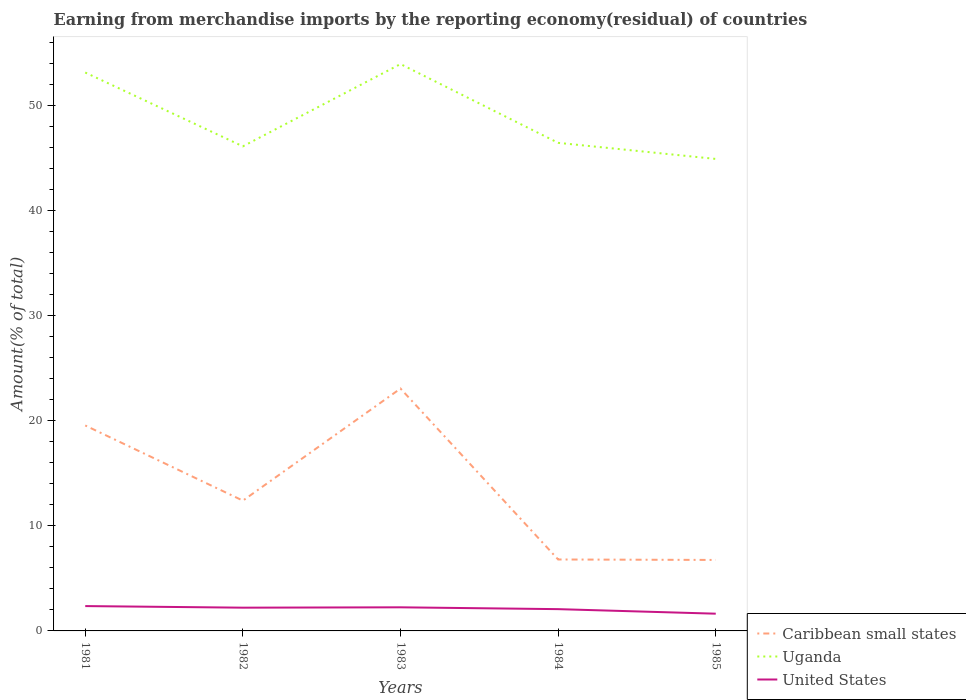Across all years, what is the maximum percentage of amount earned from merchandise imports in Uganda?
Give a very brief answer. 44.92. In which year was the percentage of amount earned from merchandise imports in Caribbean small states maximum?
Provide a succinct answer. 1985. What is the total percentage of amount earned from merchandise imports in United States in the graph?
Offer a very short reply. 0.12. What is the difference between the highest and the second highest percentage of amount earned from merchandise imports in United States?
Offer a very short reply. 0.73. What is the difference between the highest and the lowest percentage of amount earned from merchandise imports in Uganda?
Your answer should be compact. 2. Is the percentage of amount earned from merchandise imports in Caribbean small states strictly greater than the percentage of amount earned from merchandise imports in United States over the years?
Your answer should be very brief. No. How many lines are there?
Your answer should be compact. 3. What is the difference between two consecutive major ticks on the Y-axis?
Provide a short and direct response. 10. Does the graph contain grids?
Offer a terse response. No. Where does the legend appear in the graph?
Keep it short and to the point. Bottom right. How many legend labels are there?
Your answer should be very brief. 3. How are the legend labels stacked?
Your response must be concise. Vertical. What is the title of the graph?
Provide a succinct answer. Earning from merchandise imports by the reporting economy(residual) of countries. What is the label or title of the X-axis?
Give a very brief answer. Years. What is the label or title of the Y-axis?
Provide a short and direct response. Amount(% of total). What is the Amount(% of total) in Caribbean small states in 1981?
Keep it short and to the point. 19.55. What is the Amount(% of total) in Uganda in 1981?
Offer a terse response. 53.14. What is the Amount(% of total) in United States in 1981?
Ensure brevity in your answer.  2.36. What is the Amount(% of total) in Caribbean small states in 1982?
Provide a short and direct response. 12.4. What is the Amount(% of total) of Uganda in 1982?
Keep it short and to the point. 46.12. What is the Amount(% of total) in United States in 1982?
Your response must be concise. 2.21. What is the Amount(% of total) of Caribbean small states in 1983?
Make the answer very short. 23.07. What is the Amount(% of total) in Uganda in 1983?
Ensure brevity in your answer.  53.95. What is the Amount(% of total) of United States in 1983?
Offer a terse response. 2.25. What is the Amount(% of total) of Caribbean small states in 1984?
Keep it short and to the point. 6.8. What is the Amount(% of total) of Uganda in 1984?
Provide a short and direct response. 46.45. What is the Amount(% of total) of United States in 1984?
Make the answer very short. 2.07. What is the Amount(% of total) in Caribbean small states in 1985?
Make the answer very short. 6.75. What is the Amount(% of total) of Uganda in 1985?
Your answer should be compact. 44.92. What is the Amount(% of total) in United States in 1985?
Offer a very short reply. 1.64. Across all years, what is the maximum Amount(% of total) in Caribbean small states?
Your answer should be very brief. 23.07. Across all years, what is the maximum Amount(% of total) in Uganda?
Give a very brief answer. 53.95. Across all years, what is the maximum Amount(% of total) of United States?
Offer a very short reply. 2.36. Across all years, what is the minimum Amount(% of total) in Caribbean small states?
Ensure brevity in your answer.  6.75. Across all years, what is the minimum Amount(% of total) in Uganda?
Keep it short and to the point. 44.92. Across all years, what is the minimum Amount(% of total) of United States?
Give a very brief answer. 1.64. What is the total Amount(% of total) of Caribbean small states in the graph?
Offer a terse response. 68.57. What is the total Amount(% of total) in Uganda in the graph?
Give a very brief answer. 244.57. What is the total Amount(% of total) in United States in the graph?
Keep it short and to the point. 10.54. What is the difference between the Amount(% of total) in Caribbean small states in 1981 and that in 1982?
Make the answer very short. 7.15. What is the difference between the Amount(% of total) in Uganda in 1981 and that in 1982?
Your response must be concise. 7.03. What is the difference between the Amount(% of total) of United States in 1981 and that in 1982?
Ensure brevity in your answer.  0.15. What is the difference between the Amount(% of total) in Caribbean small states in 1981 and that in 1983?
Make the answer very short. -3.51. What is the difference between the Amount(% of total) in Uganda in 1981 and that in 1983?
Your response must be concise. -0.81. What is the difference between the Amount(% of total) in United States in 1981 and that in 1983?
Make the answer very short. 0.12. What is the difference between the Amount(% of total) in Caribbean small states in 1981 and that in 1984?
Provide a short and direct response. 12.75. What is the difference between the Amount(% of total) in Uganda in 1981 and that in 1984?
Ensure brevity in your answer.  6.69. What is the difference between the Amount(% of total) of United States in 1981 and that in 1984?
Make the answer very short. 0.29. What is the difference between the Amount(% of total) in Caribbean small states in 1981 and that in 1985?
Give a very brief answer. 12.8. What is the difference between the Amount(% of total) of Uganda in 1981 and that in 1985?
Make the answer very short. 8.22. What is the difference between the Amount(% of total) in United States in 1981 and that in 1985?
Keep it short and to the point. 0.73. What is the difference between the Amount(% of total) of Caribbean small states in 1982 and that in 1983?
Keep it short and to the point. -10.67. What is the difference between the Amount(% of total) in Uganda in 1982 and that in 1983?
Make the answer very short. -7.83. What is the difference between the Amount(% of total) of United States in 1982 and that in 1983?
Ensure brevity in your answer.  -0.03. What is the difference between the Amount(% of total) in Caribbean small states in 1982 and that in 1984?
Your response must be concise. 5.6. What is the difference between the Amount(% of total) of Uganda in 1982 and that in 1984?
Ensure brevity in your answer.  -0.33. What is the difference between the Amount(% of total) in United States in 1982 and that in 1984?
Give a very brief answer. 0.14. What is the difference between the Amount(% of total) of Caribbean small states in 1982 and that in 1985?
Make the answer very short. 5.65. What is the difference between the Amount(% of total) of Uganda in 1982 and that in 1985?
Provide a succinct answer. 1.2. What is the difference between the Amount(% of total) of United States in 1982 and that in 1985?
Give a very brief answer. 0.57. What is the difference between the Amount(% of total) of Caribbean small states in 1983 and that in 1984?
Ensure brevity in your answer.  16.27. What is the difference between the Amount(% of total) of Uganda in 1983 and that in 1984?
Keep it short and to the point. 7.5. What is the difference between the Amount(% of total) of United States in 1983 and that in 1984?
Your response must be concise. 0.17. What is the difference between the Amount(% of total) in Caribbean small states in 1983 and that in 1985?
Offer a terse response. 16.31. What is the difference between the Amount(% of total) of Uganda in 1983 and that in 1985?
Offer a terse response. 9.03. What is the difference between the Amount(% of total) in United States in 1983 and that in 1985?
Offer a very short reply. 0.61. What is the difference between the Amount(% of total) of Caribbean small states in 1984 and that in 1985?
Your answer should be very brief. 0.04. What is the difference between the Amount(% of total) in Uganda in 1984 and that in 1985?
Provide a succinct answer. 1.53. What is the difference between the Amount(% of total) of United States in 1984 and that in 1985?
Offer a terse response. 0.43. What is the difference between the Amount(% of total) in Caribbean small states in 1981 and the Amount(% of total) in Uganda in 1982?
Your response must be concise. -26.56. What is the difference between the Amount(% of total) of Caribbean small states in 1981 and the Amount(% of total) of United States in 1982?
Provide a short and direct response. 17.34. What is the difference between the Amount(% of total) in Uganda in 1981 and the Amount(% of total) in United States in 1982?
Your response must be concise. 50.93. What is the difference between the Amount(% of total) of Caribbean small states in 1981 and the Amount(% of total) of Uganda in 1983?
Make the answer very short. -34.39. What is the difference between the Amount(% of total) of Caribbean small states in 1981 and the Amount(% of total) of United States in 1983?
Give a very brief answer. 17.31. What is the difference between the Amount(% of total) in Uganda in 1981 and the Amount(% of total) in United States in 1983?
Make the answer very short. 50.9. What is the difference between the Amount(% of total) in Caribbean small states in 1981 and the Amount(% of total) in Uganda in 1984?
Offer a terse response. -26.9. What is the difference between the Amount(% of total) of Caribbean small states in 1981 and the Amount(% of total) of United States in 1984?
Make the answer very short. 17.48. What is the difference between the Amount(% of total) in Uganda in 1981 and the Amount(% of total) in United States in 1984?
Ensure brevity in your answer.  51.07. What is the difference between the Amount(% of total) of Caribbean small states in 1981 and the Amount(% of total) of Uganda in 1985?
Your answer should be very brief. -25.37. What is the difference between the Amount(% of total) in Caribbean small states in 1981 and the Amount(% of total) in United States in 1985?
Make the answer very short. 17.91. What is the difference between the Amount(% of total) of Uganda in 1981 and the Amount(% of total) of United States in 1985?
Offer a very short reply. 51.5. What is the difference between the Amount(% of total) of Caribbean small states in 1982 and the Amount(% of total) of Uganda in 1983?
Your answer should be compact. -41.55. What is the difference between the Amount(% of total) of Caribbean small states in 1982 and the Amount(% of total) of United States in 1983?
Offer a very short reply. 10.15. What is the difference between the Amount(% of total) in Uganda in 1982 and the Amount(% of total) in United States in 1983?
Provide a succinct answer. 43.87. What is the difference between the Amount(% of total) of Caribbean small states in 1982 and the Amount(% of total) of Uganda in 1984?
Keep it short and to the point. -34.05. What is the difference between the Amount(% of total) in Caribbean small states in 1982 and the Amount(% of total) in United States in 1984?
Your answer should be very brief. 10.33. What is the difference between the Amount(% of total) in Uganda in 1982 and the Amount(% of total) in United States in 1984?
Make the answer very short. 44.04. What is the difference between the Amount(% of total) of Caribbean small states in 1982 and the Amount(% of total) of Uganda in 1985?
Provide a succinct answer. -32.52. What is the difference between the Amount(% of total) in Caribbean small states in 1982 and the Amount(% of total) in United States in 1985?
Give a very brief answer. 10.76. What is the difference between the Amount(% of total) in Uganda in 1982 and the Amount(% of total) in United States in 1985?
Give a very brief answer. 44.48. What is the difference between the Amount(% of total) of Caribbean small states in 1983 and the Amount(% of total) of Uganda in 1984?
Make the answer very short. -23.38. What is the difference between the Amount(% of total) in Caribbean small states in 1983 and the Amount(% of total) in United States in 1984?
Provide a short and direct response. 20.99. What is the difference between the Amount(% of total) of Uganda in 1983 and the Amount(% of total) of United States in 1984?
Keep it short and to the point. 51.88. What is the difference between the Amount(% of total) of Caribbean small states in 1983 and the Amount(% of total) of Uganda in 1985?
Ensure brevity in your answer.  -21.85. What is the difference between the Amount(% of total) of Caribbean small states in 1983 and the Amount(% of total) of United States in 1985?
Provide a succinct answer. 21.43. What is the difference between the Amount(% of total) of Uganda in 1983 and the Amount(% of total) of United States in 1985?
Ensure brevity in your answer.  52.31. What is the difference between the Amount(% of total) in Caribbean small states in 1984 and the Amount(% of total) in Uganda in 1985?
Ensure brevity in your answer.  -38.12. What is the difference between the Amount(% of total) of Caribbean small states in 1984 and the Amount(% of total) of United States in 1985?
Your response must be concise. 5.16. What is the difference between the Amount(% of total) of Uganda in 1984 and the Amount(% of total) of United States in 1985?
Give a very brief answer. 44.81. What is the average Amount(% of total) of Caribbean small states per year?
Offer a very short reply. 13.71. What is the average Amount(% of total) of Uganda per year?
Provide a succinct answer. 48.91. What is the average Amount(% of total) in United States per year?
Your answer should be very brief. 2.11. In the year 1981, what is the difference between the Amount(% of total) of Caribbean small states and Amount(% of total) of Uganda?
Provide a succinct answer. -33.59. In the year 1981, what is the difference between the Amount(% of total) in Caribbean small states and Amount(% of total) in United States?
Your response must be concise. 17.19. In the year 1981, what is the difference between the Amount(% of total) in Uganda and Amount(% of total) in United States?
Offer a terse response. 50.78. In the year 1982, what is the difference between the Amount(% of total) in Caribbean small states and Amount(% of total) in Uganda?
Your answer should be very brief. -33.72. In the year 1982, what is the difference between the Amount(% of total) of Caribbean small states and Amount(% of total) of United States?
Keep it short and to the point. 10.19. In the year 1982, what is the difference between the Amount(% of total) of Uganda and Amount(% of total) of United States?
Provide a short and direct response. 43.9. In the year 1983, what is the difference between the Amount(% of total) of Caribbean small states and Amount(% of total) of Uganda?
Keep it short and to the point. -30.88. In the year 1983, what is the difference between the Amount(% of total) of Caribbean small states and Amount(% of total) of United States?
Ensure brevity in your answer.  20.82. In the year 1983, what is the difference between the Amount(% of total) of Uganda and Amount(% of total) of United States?
Ensure brevity in your answer.  51.7. In the year 1984, what is the difference between the Amount(% of total) of Caribbean small states and Amount(% of total) of Uganda?
Keep it short and to the point. -39.65. In the year 1984, what is the difference between the Amount(% of total) in Caribbean small states and Amount(% of total) in United States?
Ensure brevity in your answer.  4.73. In the year 1984, what is the difference between the Amount(% of total) of Uganda and Amount(% of total) of United States?
Your answer should be very brief. 44.38. In the year 1985, what is the difference between the Amount(% of total) of Caribbean small states and Amount(% of total) of Uganda?
Offer a terse response. -38.16. In the year 1985, what is the difference between the Amount(% of total) in Caribbean small states and Amount(% of total) in United States?
Make the answer very short. 5.12. In the year 1985, what is the difference between the Amount(% of total) of Uganda and Amount(% of total) of United States?
Ensure brevity in your answer.  43.28. What is the ratio of the Amount(% of total) of Caribbean small states in 1981 to that in 1982?
Provide a succinct answer. 1.58. What is the ratio of the Amount(% of total) in Uganda in 1981 to that in 1982?
Your answer should be very brief. 1.15. What is the ratio of the Amount(% of total) in United States in 1981 to that in 1982?
Ensure brevity in your answer.  1.07. What is the ratio of the Amount(% of total) in Caribbean small states in 1981 to that in 1983?
Ensure brevity in your answer.  0.85. What is the ratio of the Amount(% of total) of Uganda in 1981 to that in 1983?
Offer a very short reply. 0.99. What is the ratio of the Amount(% of total) in United States in 1981 to that in 1983?
Offer a very short reply. 1.05. What is the ratio of the Amount(% of total) in Caribbean small states in 1981 to that in 1984?
Ensure brevity in your answer.  2.88. What is the ratio of the Amount(% of total) in Uganda in 1981 to that in 1984?
Offer a terse response. 1.14. What is the ratio of the Amount(% of total) of United States in 1981 to that in 1984?
Make the answer very short. 1.14. What is the ratio of the Amount(% of total) of Caribbean small states in 1981 to that in 1985?
Your answer should be compact. 2.89. What is the ratio of the Amount(% of total) of Uganda in 1981 to that in 1985?
Keep it short and to the point. 1.18. What is the ratio of the Amount(% of total) of United States in 1981 to that in 1985?
Ensure brevity in your answer.  1.44. What is the ratio of the Amount(% of total) in Caribbean small states in 1982 to that in 1983?
Keep it short and to the point. 0.54. What is the ratio of the Amount(% of total) of Uganda in 1982 to that in 1983?
Your answer should be compact. 0.85. What is the ratio of the Amount(% of total) of United States in 1982 to that in 1983?
Make the answer very short. 0.98. What is the ratio of the Amount(% of total) of Caribbean small states in 1982 to that in 1984?
Offer a terse response. 1.82. What is the ratio of the Amount(% of total) in Uganda in 1982 to that in 1984?
Give a very brief answer. 0.99. What is the ratio of the Amount(% of total) in United States in 1982 to that in 1984?
Offer a very short reply. 1.07. What is the ratio of the Amount(% of total) in Caribbean small states in 1982 to that in 1985?
Provide a succinct answer. 1.84. What is the ratio of the Amount(% of total) in Uganda in 1982 to that in 1985?
Provide a succinct answer. 1.03. What is the ratio of the Amount(% of total) of United States in 1982 to that in 1985?
Give a very brief answer. 1.35. What is the ratio of the Amount(% of total) of Caribbean small states in 1983 to that in 1984?
Your response must be concise. 3.39. What is the ratio of the Amount(% of total) in Uganda in 1983 to that in 1984?
Provide a succinct answer. 1.16. What is the ratio of the Amount(% of total) in United States in 1983 to that in 1984?
Offer a very short reply. 1.08. What is the ratio of the Amount(% of total) in Caribbean small states in 1983 to that in 1985?
Your answer should be compact. 3.41. What is the ratio of the Amount(% of total) in Uganda in 1983 to that in 1985?
Keep it short and to the point. 1.2. What is the ratio of the Amount(% of total) in United States in 1983 to that in 1985?
Offer a very short reply. 1.37. What is the ratio of the Amount(% of total) in Caribbean small states in 1984 to that in 1985?
Provide a succinct answer. 1.01. What is the ratio of the Amount(% of total) in Uganda in 1984 to that in 1985?
Your response must be concise. 1.03. What is the ratio of the Amount(% of total) in United States in 1984 to that in 1985?
Your answer should be compact. 1.26. What is the difference between the highest and the second highest Amount(% of total) of Caribbean small states?
Provide a succinct answer. 3.51. What is the difference between the highest and the second highest Amount(% of total) of Uganda?
Provide a short and direct response. 0.81. What is the difference between the highest and the second highest Amount(% of total) in United States?
Your answer should be compact. 0.12. What is the difference between the highest and the lowest Amount(% of total) in Caribbean small states?
Your answer should be very brief. 16.31. What is the difference between the highest and the lowest Amount(% of total) in Uganda?
Offer a terse response. 9.03. What is the difference between the highest and the lowest Amount(% of total) in United States?
Your answer should be very brief. 0.73. 